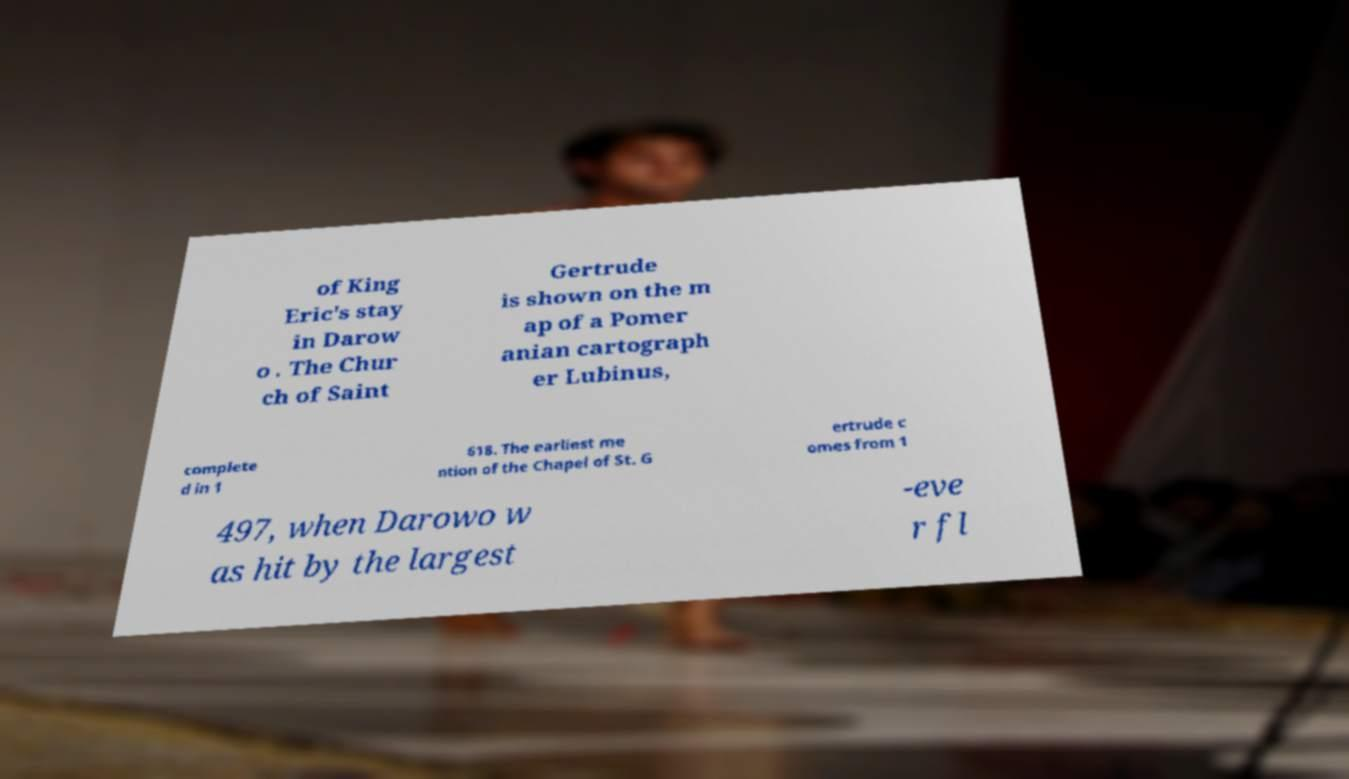Could you assist in decoding the text presented in this image and type it out clearly? of King Eric's stay in Darow o . The Chur ch of Saint Gertrude is shown on the m ap of a Pomer anian cartograph er Lubinus, complete d in 1 618. The earliest me ntion of the Chapel of St. G ertrude c omes from 1 497, when Darowo w as hit by the largest -eve r fl 